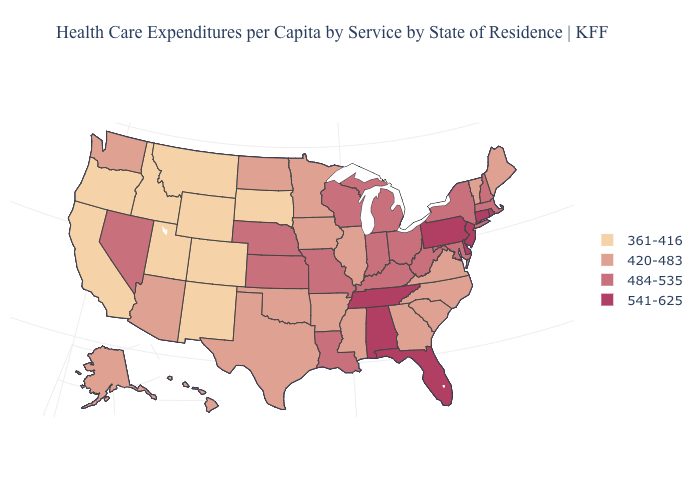Is the legend a continuous bar?
Concise answer only. No. Among the states that border Delaware , which have the lowest value?
Give a very brief answer. Maryland. What is the value of Oklahoma?
Give a very brief answer. 420-483. Name the states that have a value in the range 541-625?
Quick response, please. Alabama, Connecticut, Delaware, Florida, New Jersey, Pennsylvania, Rhode Island, Tennessee. What is the value of New York?
Be succinct. 484-535. Does Texas have the lowest value in the USA?
Give a very brief answer. No. Does Utah have the highest value in the West?
Be succinct. No. Name the states that have a value in the range 541-625?
Answer briefly. Alabama, Connecticut, Delaware, Florida, New Jersey, Pennsylvania, Rhode Island, Tennessee. What is the lowest value in states that border Utah?
Concise answer only. 361-416. What is the highest value in states that border Texas?
Be succinct. 484-535. What is the value of Colorado?
Quick response, please. 361-416. Among the states that border Oregon , which have the lowest value?
Write a very short answer. California, Idaho. Which states have the highest value in the USA?
Answer briefly. Alabama, Connecticut, Delaware, Florida, New Jersey, Pennsylvania, Rhode Island, Tennessee. Among the states that border Colorado , which have the highest value?
Short answer required. Kansas, Nebraska. Does Rhode Island have the same value as Florida?
Give a very brief answer. Yes. 